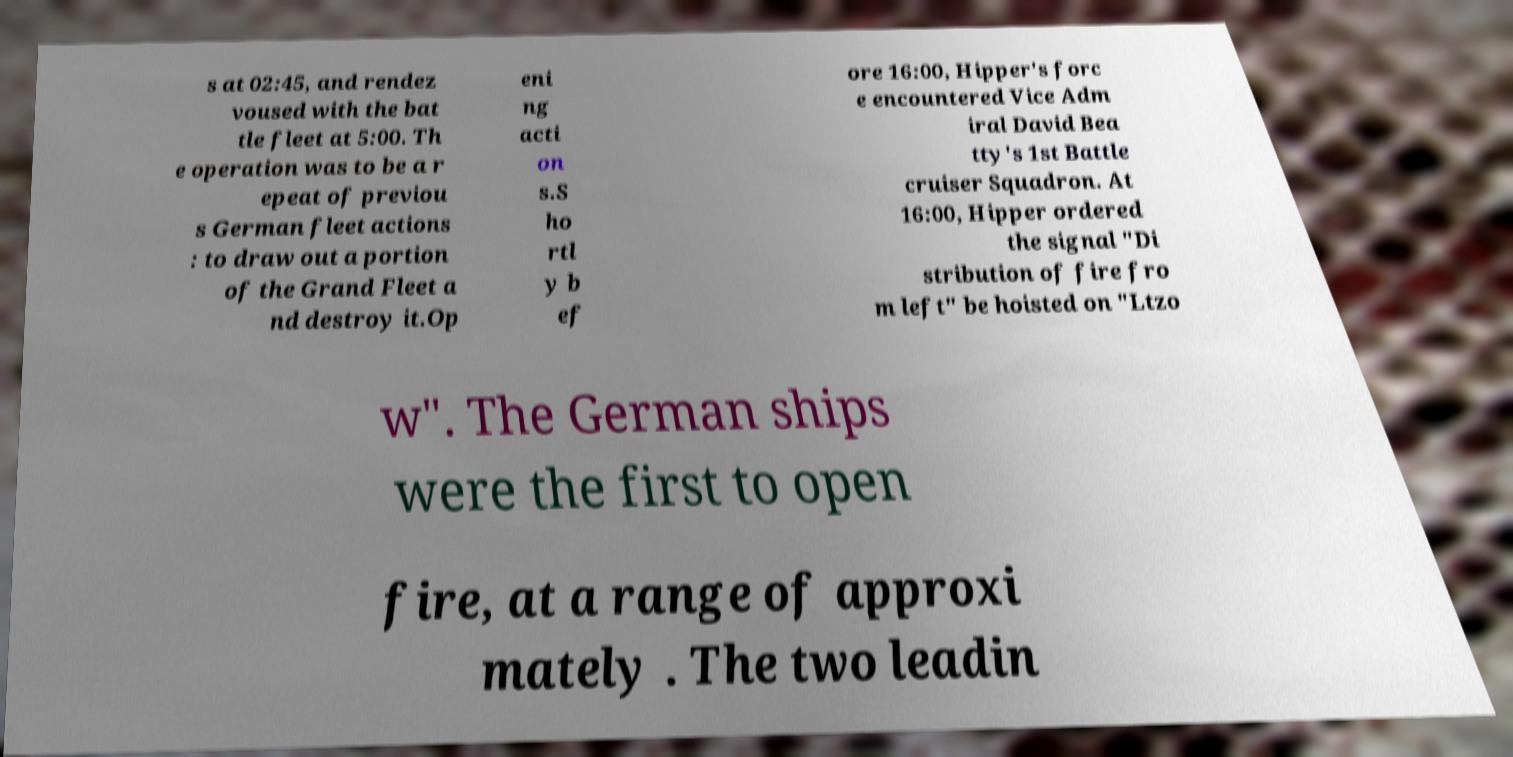For documentation purposes, I need the text within this image transcribed. Could you provide that? s at 02:45, and rendez voused with the bat tle fleet at 5:00. Th e operation was to be a r epeat of previou s German fleet actions : to draw out a portion of the Grand Fleet a nd destroy it.Op eni ng acti on s.S ho rtl y b ef ore 16:00, Hipper's forc e encountered Vice Adm iral David Bea tty's 1st Battle cruiser Squadron. At 16:00, Hipper ordered the signal "Di stribution of fire fro m left" be hoisted on "Ltzo w". The German ships were the first to open fire, at a range of approxi mately . The two leadin 